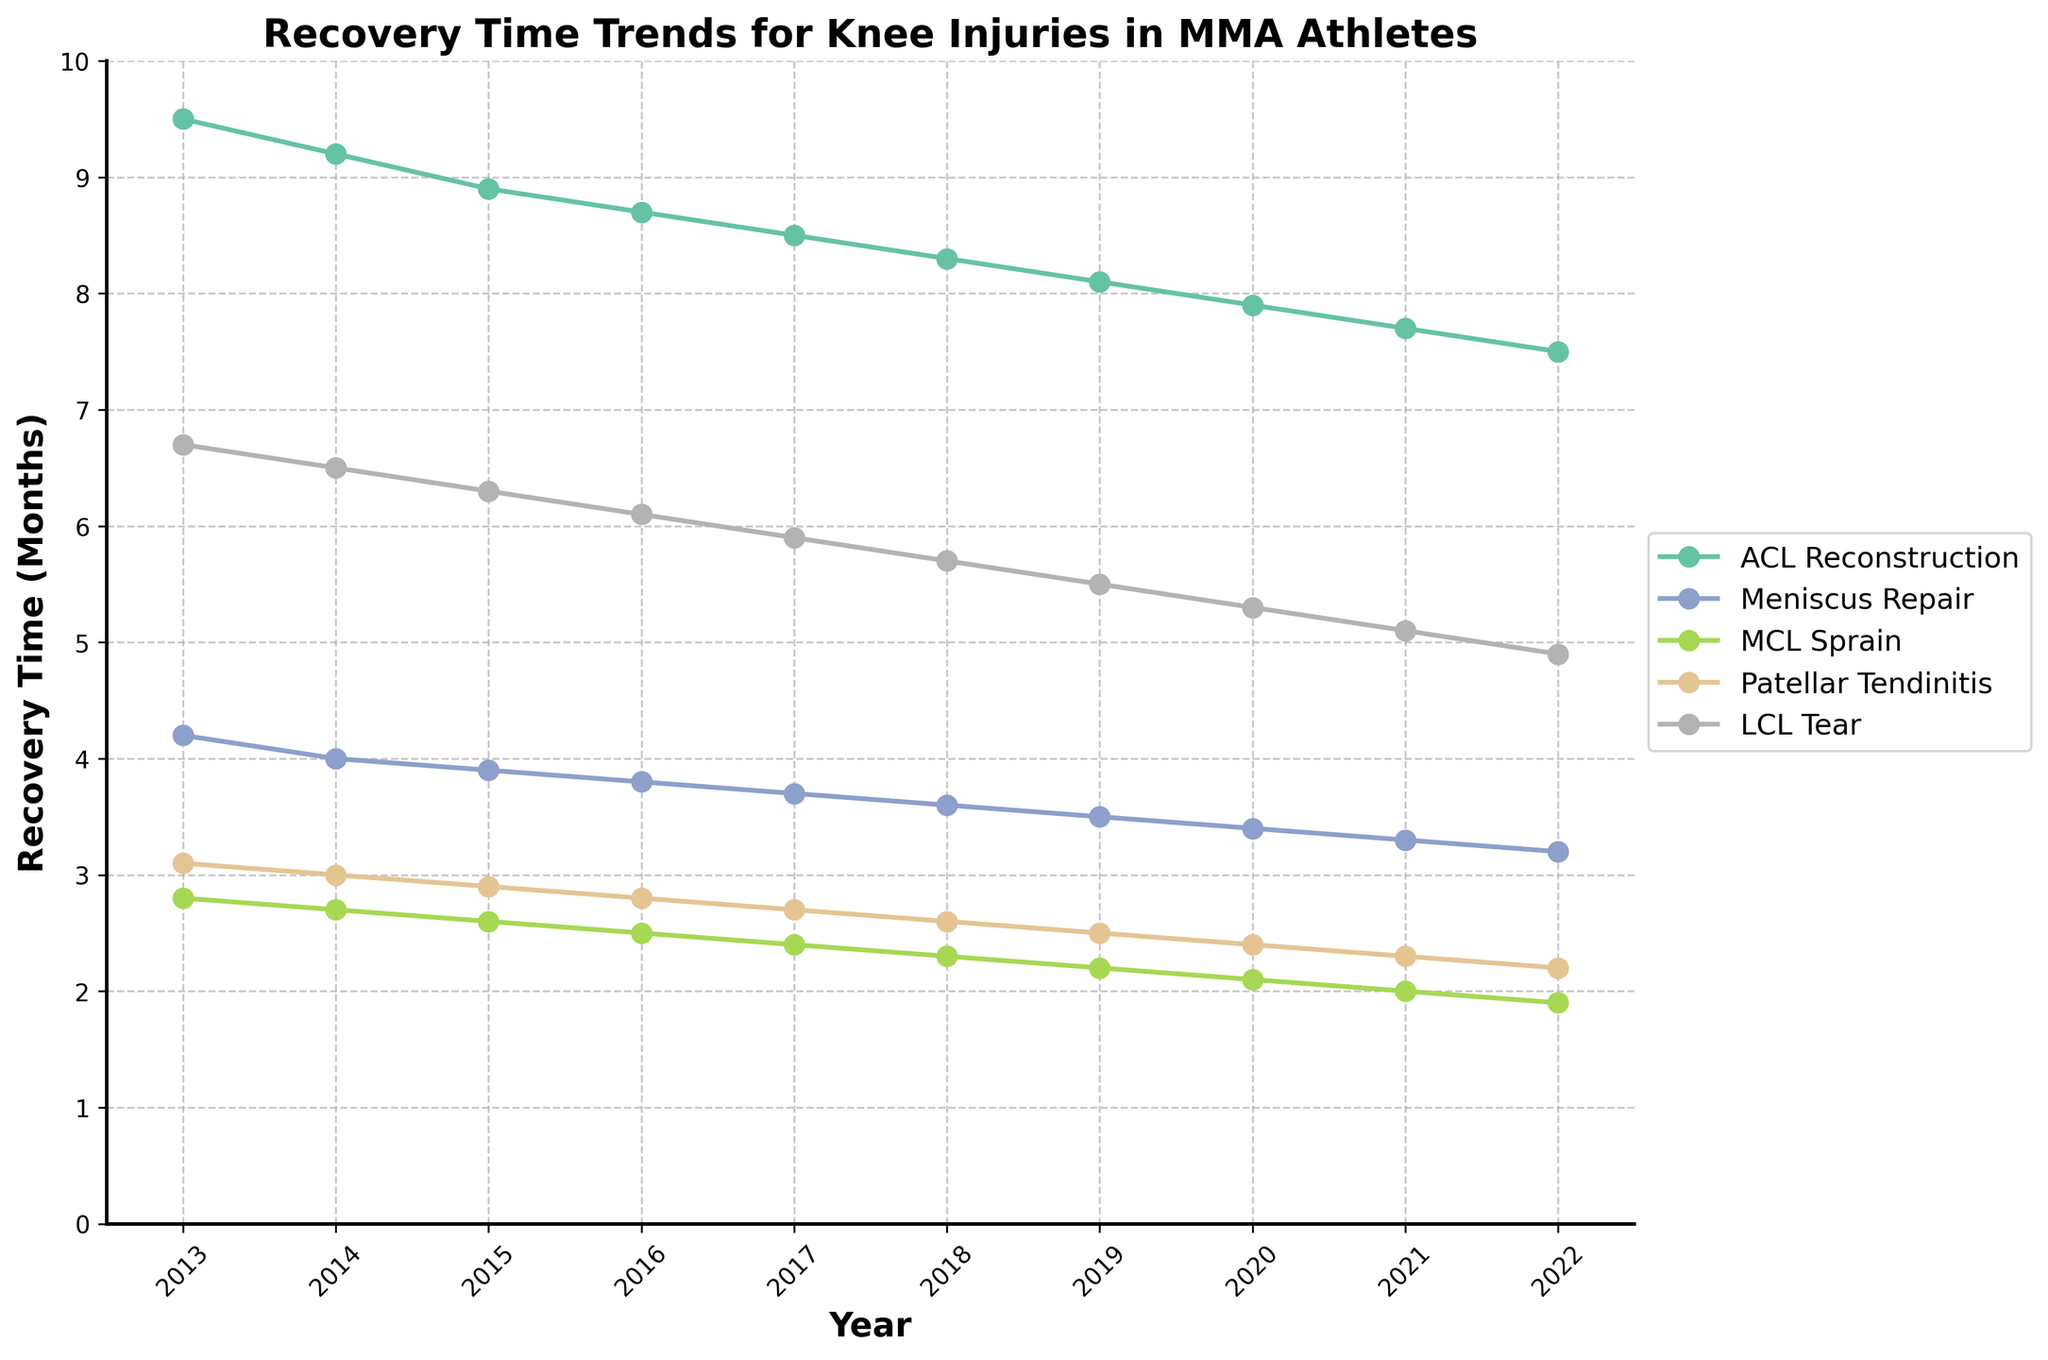Which knee injury has seen the most significant decrease in recovery time from 2013 to 2022? To determine this, observe the overall trend in recovery time for each injury over the years. The ACL Reconstruction recovery time decreased from 9.5 months in 2013 to 7.5 months in 2022. The Meniscus Repair recovery time decreased from 4.2 to 3.2 months, MCL Sprain from 2.8 to 1.9 months, Patellar Tendinitis from 3.1 to 2.2 months, and LCL Tear from 6.7 to 4.9 months. Therefore, ACL Reconstruction has the most significant decrease.
Answer: ACL Reconstruction How does the recovery time for MCL Sprain in 2018 compare to that for Meniscus Repair in the same year? Check the recovery times for both injuries in the year 2018. The recovery time for MCL Sprain in 2018 is 2.3 months, and for Meniscus Repair, it is 3.6 months. Therefore, MCL Sprain recovery time is shorter.
Answer: MCL Sprain is shorter Which knee injury consistently had the shortest recovery time from 2013 to 2022? Analyze the trends for each injury over the decade. MCL Sprain consistently has the shortest recovery times compared to other injuries, with its highest being 2.8 months in 2013.
Answer: MCL Sprain What is the total decrease in recovery time for LCL Tear from 2013 to 2022? Subtract the recovery time of LCL Tear in 2022 from that in 2013. The recovery time decreased from 6.7 months to 4.9 months. The total decrease is 6.7 - 4.9 = 1.8 months.
Answer: 1.8 months Which two injuries had the closest recovery times in 2020, and what was the difference between them? Compare the recovery times for all injuries in 2020. Patellar Tendinitis has a recovery time of 2.4 months, and MCL Sprain has 2.1 months. The difference is 2.4 - 2.1 = 0.3 months.
Answer: Patellar Tendinitis and MCL Sprain, 0.3 months On average, how much did the recovery time for Meniscus Repair decrease per year from 2013 to 2022? First, find the total decrease: 4.2 months (2013) to 3.2 months (2022), which is 4.2 - 3.2 = 1.0 months. There are 9 intervals between 2013 and 2022, so the average yearly decrease is 1.0 / 9 ≈ 0.11 months per year.
Answer: 0.11 months per year In which year did ACL Reconstruction recovery time fall below 8 months for the first time? Find the year when the ACL Reconstruction recovery time first drops below 8 months. This occurs in 2020, where the time is 7.9 months.
Answer: 2020 What was the recovery time for Patellar Tendinitis in 2016, and how did it change by 2021? Look at the values for Patellar Tendinitis in 2016 and 2021. The recovery time in 2016 was 2.8 months, and it decreased to 2.3 months by 2021. The change is 2.8 - 2.3 = 0.5 months.
Answer: 2.8 months (2016), decreased by 0.5 months 